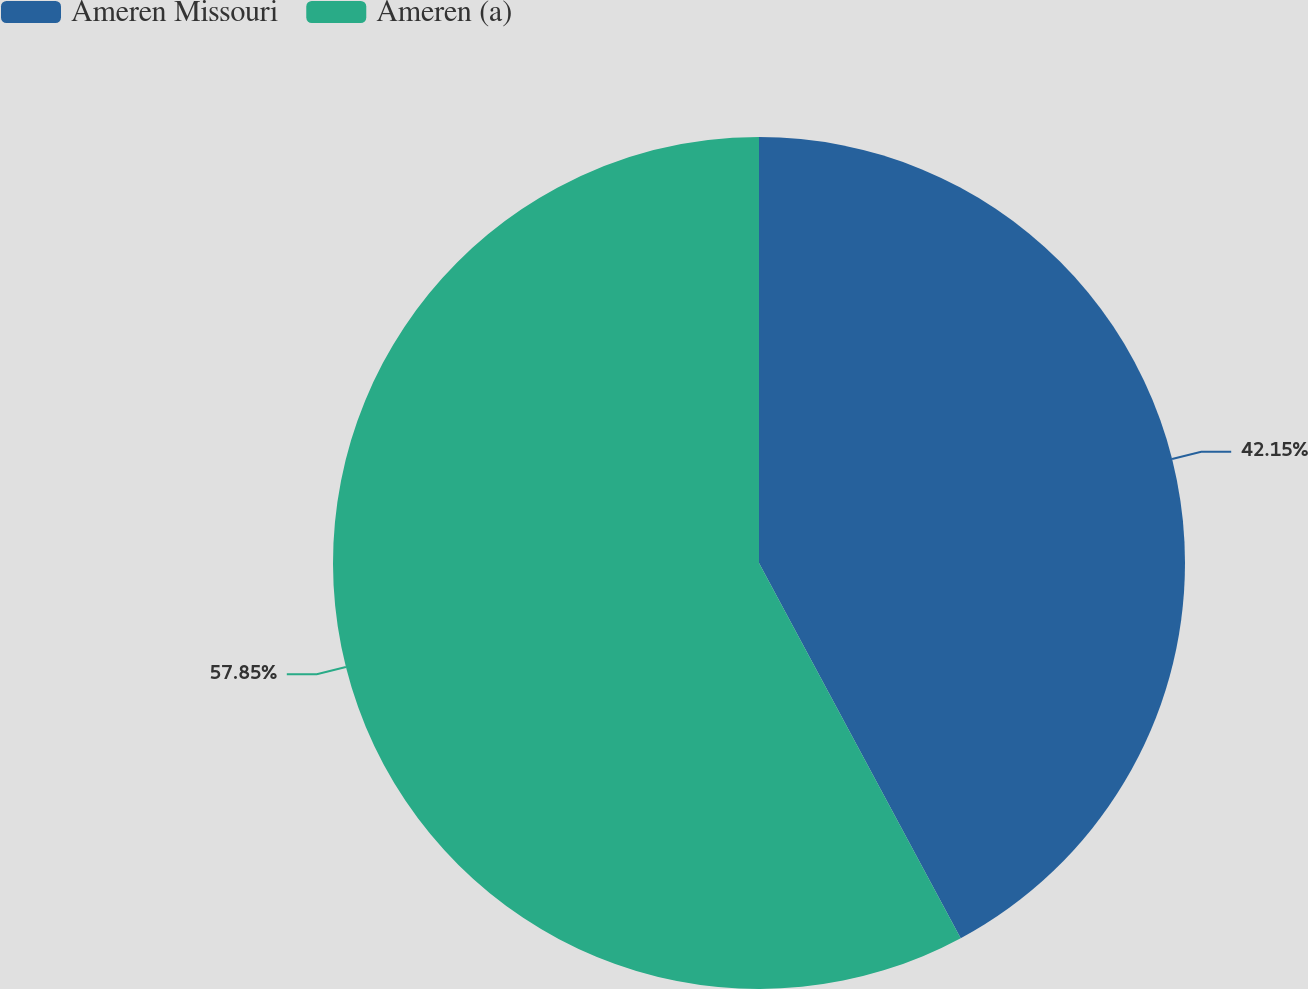Convert chart to OTSL. <chart><loc_0><loc_0><loc_500><loc_500><pie_chart><fcel>Ameren Missouri<fcel>Ameren (a)<nl><fcel>42.15%<fcel>57.85%<nl></chart> 